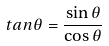Convert formula to latex. <formula><loc_0><loc_0><loc_500><loc_500>t a n \theta = \frac { \sin \theta } { \cos \theta }</formula> 